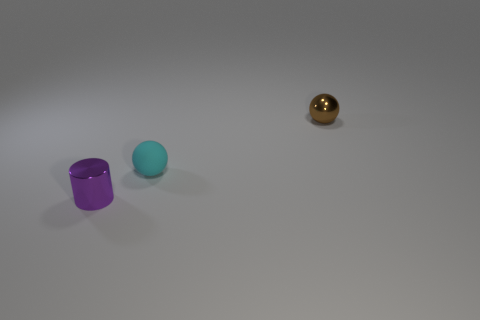Do the cyan matte object and the small metal thing that is on the left side of the small brown metal thing have the same shape?
Offer a terse response. No. Is the number of shiny things that are in front of the cyan sphere less than the number of red balls?
Make the answer very short. No. Does the tiny purple thing have the same shape as the brown object?
Keep it short and to the point. No. The cylinder that is made of the same material as the small brown object is what size?
Make the answer very short. Small. Are there fewer tiny red cubes than tiny purple shiny cylinders?
Provide a short and direct response. Yes. How many big things are matte spheres or brown metallic objects?
Your answer should be very brief. 0. What number of small objects are to the left of the brown sphere and behind the tiny cylinder?
Keep it short and to the point. 1. Is the number of green metal things greater than the number of small cyan things?
Offer a very short reply. No. What number of other objects are the same shape as the brown object?
Your answer should be very brief. 1. Do the tiny cylinder and the matte sphere have the same color?
Your answer should be compact. No. 